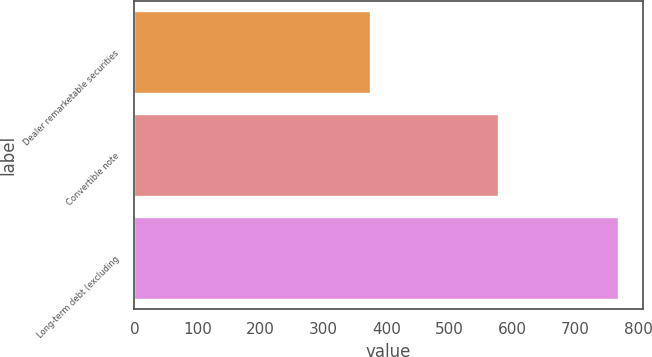<chart> <loc_0><loc_0><loc_500><loc_500><bar_chart><fcel>Dealer remarketable securities<fcel>Convertible note<fcel>Long-term debt (excluding<nl><fcel>374<fcel>577<fcel>768<nl></chart> 